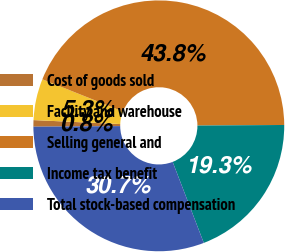<chart> <loc_0><loc_0><loc_500><loc_500><pie_chart><fcel>Cost of goods sold<fcel>Facility and warehouse<fcel>Selling general and<fcel>Income tax benefit<fcel>Total stock-based compensation<nl><fcel>0.84%<fcel>5.32%<fcel>43.84%<fcel>19.27%<fcel>30.73%<nl></chart> 